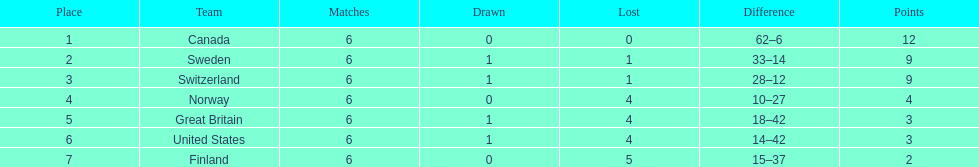During the 1951 world ice hockey championships, what was the difference between the first and last place teams for number of games won ? 5. Would you be able to parse every entry in this table? {'header': ['Place', 'Team', 'Matches', 'Drawn', 'Lost', 'Difference', 'Points'], 'rows': [['1', 'Canada', '6', '0', '0', '62–6', '12'], ['2', 'Sweden', '6', '1', '1', '33–14', '9'], ['3', 'Switzerland', '6', '1', '1', '28–12', '9'], ['4', 'Norway', '6', '0', '4', '10–27', '4'], ['5', 'Great Britain', '6', '1', '4', '18–42', '3'], ['6', 'United States', '6', '1', '4', '14–42', '3'], ['7', 'Finland', '6', '0', '5', '15–37', '2']]} 